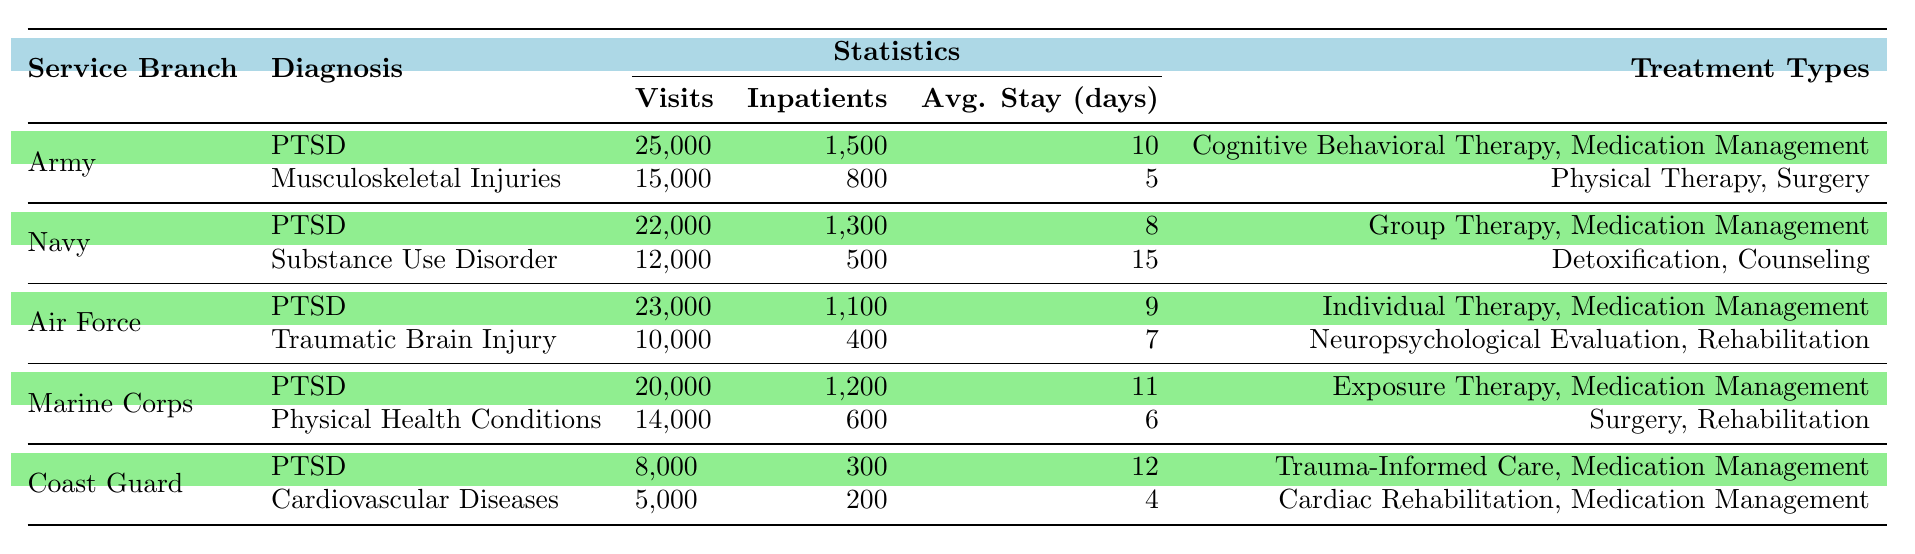What is the total number of visits for PTSD across all service branches? To find the total visits for PTSD, sum the visits for each service branch: Army (25,000) + Navy (22,000) + Air Force (23,000) + Marine Corps (20,000) + Coast Guard (8,000) = 25,000 + 22,000 + 23,000 + 20,000 + 8,000 = 98,000.
Answer: 98,000 Which service branch has the highest number of inpatient visits for Substance Use Disorder? Only the Navy has a diagnosis for Substance Use Disorder with 500 inpatient visits. Since no other branch has this diagnosis, the Navy has the highest number of inpatient visits for this condition.
Answer: Navy How many average days do patients with cardiovascular diseases in the Coast Guard stay in the hospital? According to the table, the average stay for patients diagnosed with cardiovascular diseases in the Coast Guard is 4 days, as directly stated in the table under the respective column.
Answer: 4 days What is the difference in the number of visits for PTSD between the Army and the Air Force? To find the difference, subtract the number of visits for PTSD in the Air Force (23,000) from that in the Army (25,000): 25,000 - 23,000 = 2,000.
Answer: 2,000 Which service branch has the highest average inpatient stay for PTSD? Checking the average days stay for PTSD: Army (10), Navy (8), Air Force (9), Marine Corps (11), Coast Guard (12). The highest average stay is for the Coast Guard, at 12 days.
Answer: Coast Guard Is the total number of inpatient visits for Musculoskeletal Injuries in the Army greater than those for Substance Use Disorder in the Navy? The Army has 800 inpatient visits for Musculoskeletal Injuries, while the Navy has 500 inpatient visits for Substance Use Disorder. Since 800 is greater than 500, the statement is true.
Answer: Yes Which treatment type for PTSD is unique to the Marines? The Marines provide Exposure Therapy as a treatment type for PTSD, while it does not appear in the treatment types for other branches.
Answer: Exposure Therapy How many total inpatient visits are there for PTSD across the Navy and Marine Corps? The total inpatient visits for PTSD in the Navy are 1,300 and in the Marine Corps are 1,200. Adding these figures gives 1,300 + 1,200 = 2,500 total inpatient visits.
Answer: 2,500 What is the least number of visits for any diagnosis across all service branches? Reviewing the diagnosis visit counts: Coast Guard PTSD (8,000), Coast Guard Cardiovascular Diseases (5,000), Navy Substance Use Disorder (12,000), Air Force Traumatic Brain Injury (10,000), etc. The least is 5,000 visits for Cardiovascular Diseases in the Coast Guard.
Answer: 5,000 Which diagnosis has the highest average days stay across all branches? Average days stay for each diagnosis: PTSD (Army: 10, Navy: 8, Air Force: 9, Marine Corps: 11, Coast Guard: 12), Musculoskeletal Injuries (Army: 5), Substance Use Disorder (Navy: 15), Traumatic Brain Injury (Air Force: 7), Physical Health Conditions (Marine Corps: 6), Cardiovascular Diseases (Coast Guard: 4). The highest is 15 days for Substance Use Disorder in the Navy.
Answer: Substance Use Disorder 